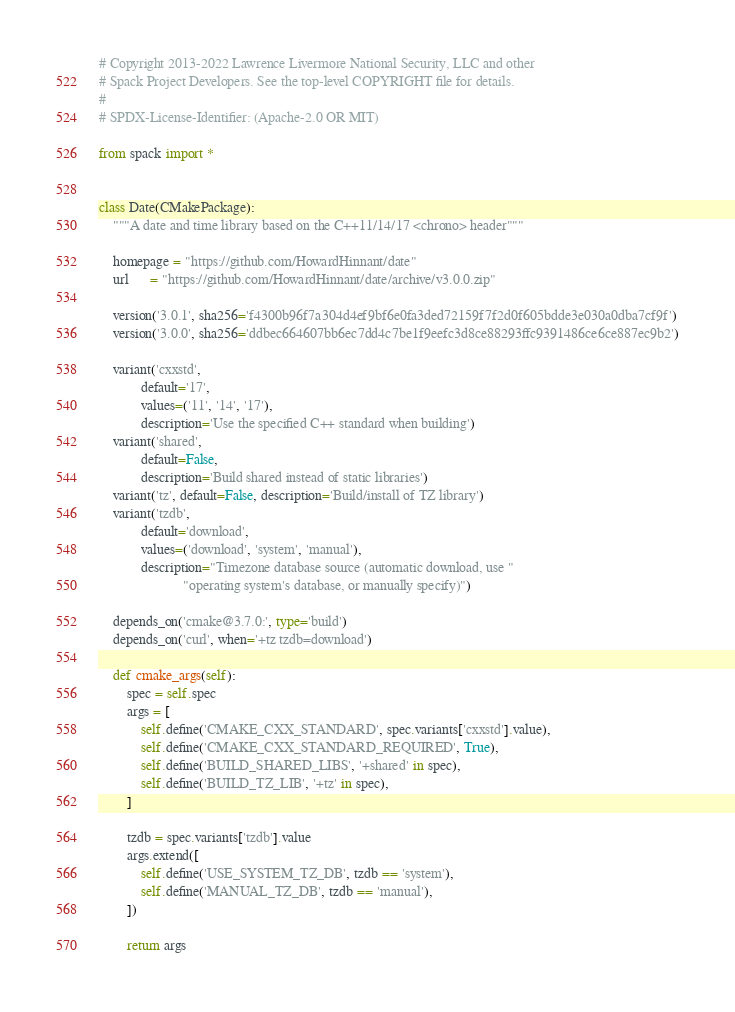<code> <loc_0><loc_0><loc_500><loc_500><_Python_># Copyright 2013-2022 Lawrence Livermore National Security, LLC and other
# Spack Project Developers. See the top-level COPYRIGHT file for details.
#
# SPDX-License-Identifier: (Apache-2.0 OR MIT)

from spack import *


class Date(CMakePackage):
    """A date and time library based on the C++11/14/17 <chrono> header"""

    homepage = "https://github.com/HowardHinnant/date"
    url      = "https://github.com/HowardHinnant/date/archive/v3.0.0.zip"

    version('3.0.1', sha256='f4300b96f7a304d4ef9bf6e0fa3ded72159f7f2d0f605bdde3e030a0dba7cf9f')
    version('3.0.0', sha256='ddbec664607bb6ec7dd4c7be1f9eefc3d8ce88293ffc9391486ce6ce887ec9b2')

    variant('cxxstd',
            default='17',
            values=('11', '14', '17'),
            description='Use the specified C++ standard when building')
    variant('shared',
            default=False,
            description='Build shared instead of static libraries')
    variant('tz', default=False, description='Build/install of TZ library')
    variant('tzdb',
            default='download',
            values=('download', 'system', 'manual'),
            description="Timezone database source (automatic download, use "
                        "operating system's database, or manually specify)")

    depends_on('cmake@3.7.0:', type='build')
    depends_on('curl', when='+tz tzdb=download')

    def cmake_args(self):
        spec = self.spec
        args = [
            self.define('CMAKE_CXX_STANDARD', spec.variants['cxxstd'].value),
            self.define('CMAKE_CXX_STANDARD_REQUIRED', True),
            self.define('BUILD_SHARED_LIBS', '+shared' in spec),
            self.define('BUILD_TZ_LIB', '+tz' in spec),
        ]

        tzdb = spec.variants['tzdb'].value
        args.extend([
            self.define('USE_SYSTEM_TZ_DB', tzdb == 'system'),
            self.define('MANUAL_TZ_DB', tzdb == 'manual'),
        ])

        return args
</code> 